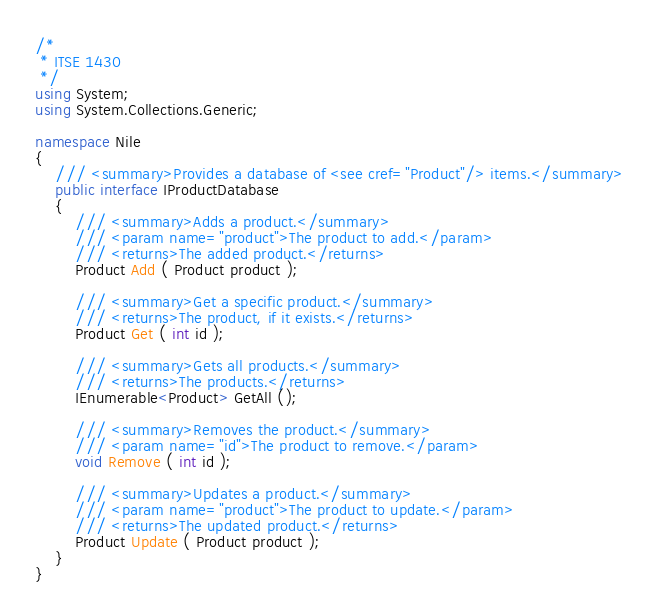Convert code to text. <code><loc_0><loc_0><loc_500><loc_500><_C#_>/*
 * ITSE 1430
 */
using System;
using System.Collections.Generic;

namespace Nile
{
    /// <summary>Provides a database of <see cref="Product"/> items.</summary>
    public interface IProductDatabase
    {
        /// <summary>Adds a product.</summary>
        /// <param name="product">The product to add.</param>
        /// <returns>The added product.</returns>
        Product Add ( Product product );

        /// <summary>Get a specific product.</summary>
        /// <returns>The product, if it exists.</returns>
        Product Get ( int id );

        /// <summary>Gets all products.</summary>
        /// <returns>The products.</returns>
        IEnumerable<Product> GetAll ();

        /// <summary>Removes the product.</summary>
        /// <param name="id">The product to remove.</param>
        void Remove ( int id );

        /// <summary>Updates a product.</summary>
        /// <param name="product">The product to update.</param>
        /// <returns>The updated product.</returns>
        Product Update ( Product product );
    }
}
</code> 